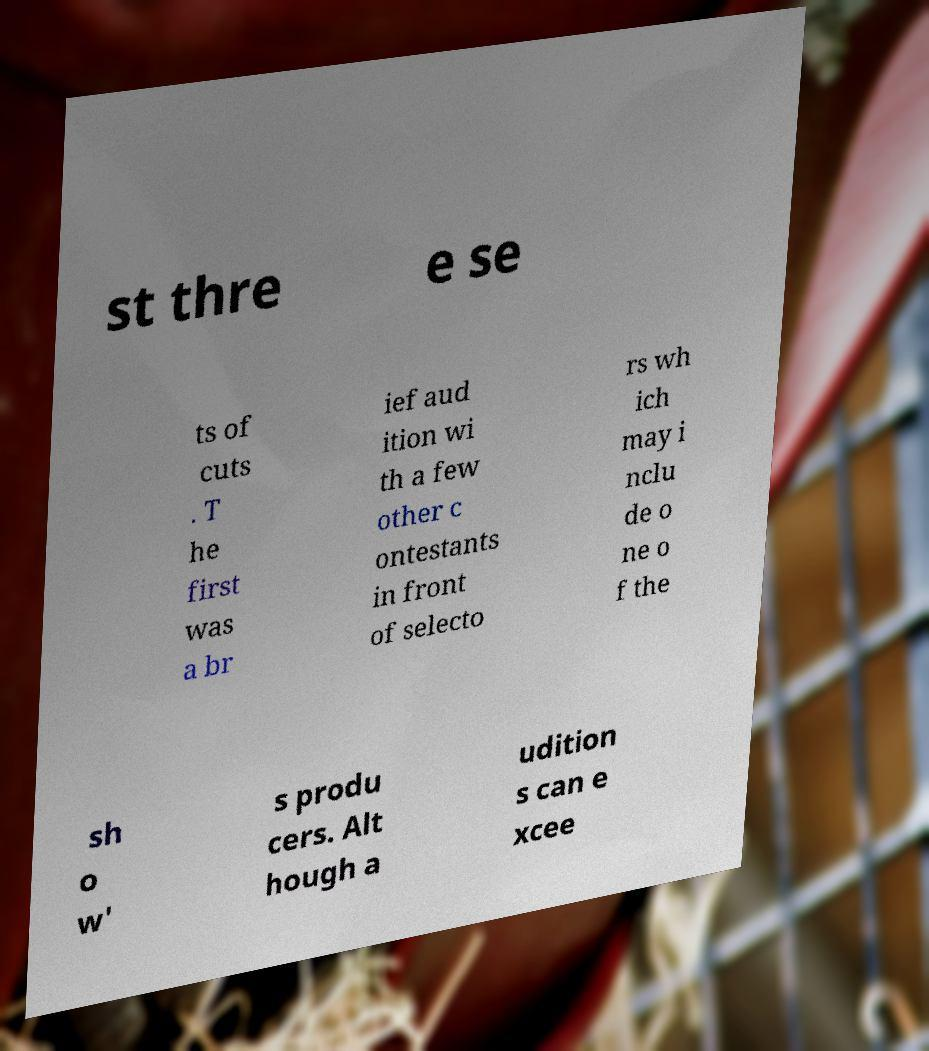Please identify and transcribe the text found in this image. st thre e se ts of cuts . T he first was a br ief aud ition wi th a few other c ontestants in front of selecto rs wh ich may i nclu de o ne o f the sh o w' s produ cers. Alt hough a udition s can e xcee 